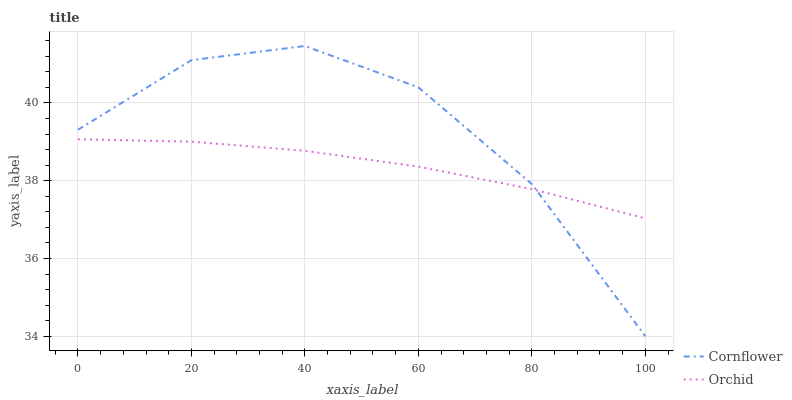Does Orchid have the minimum area under the curve?
Answer yes or no. Yes. Does Cornflower have the maximum area under the curve?
Answer yes or no. Yes. Does Orchid have the maximum area under the curve?
Answer yes or no. No. Is Orchid the smoothest?
Answer yes or no. Yes. Is Cornflower the roughest?
Answer yes or no. Yes. Is Orchid the roughest?
Answer yes or no. No. Does Cornflower have the lowest value?
Answer yes or no. Yes. Does Orchid have the lowest value?
Answer yes or no. No. Does Cornflower have the highest value?
Answer yes or no. Yes. Does Orchid have the highest value?
Answer yes or no. No. Does Cornflower intersect Orchid?
Answer yes or no. Yes. Is Cornflower less than Orchid?
Answer yes or no. No. Is Cornflower greater than Orchid?
Answer yes or no. No. 